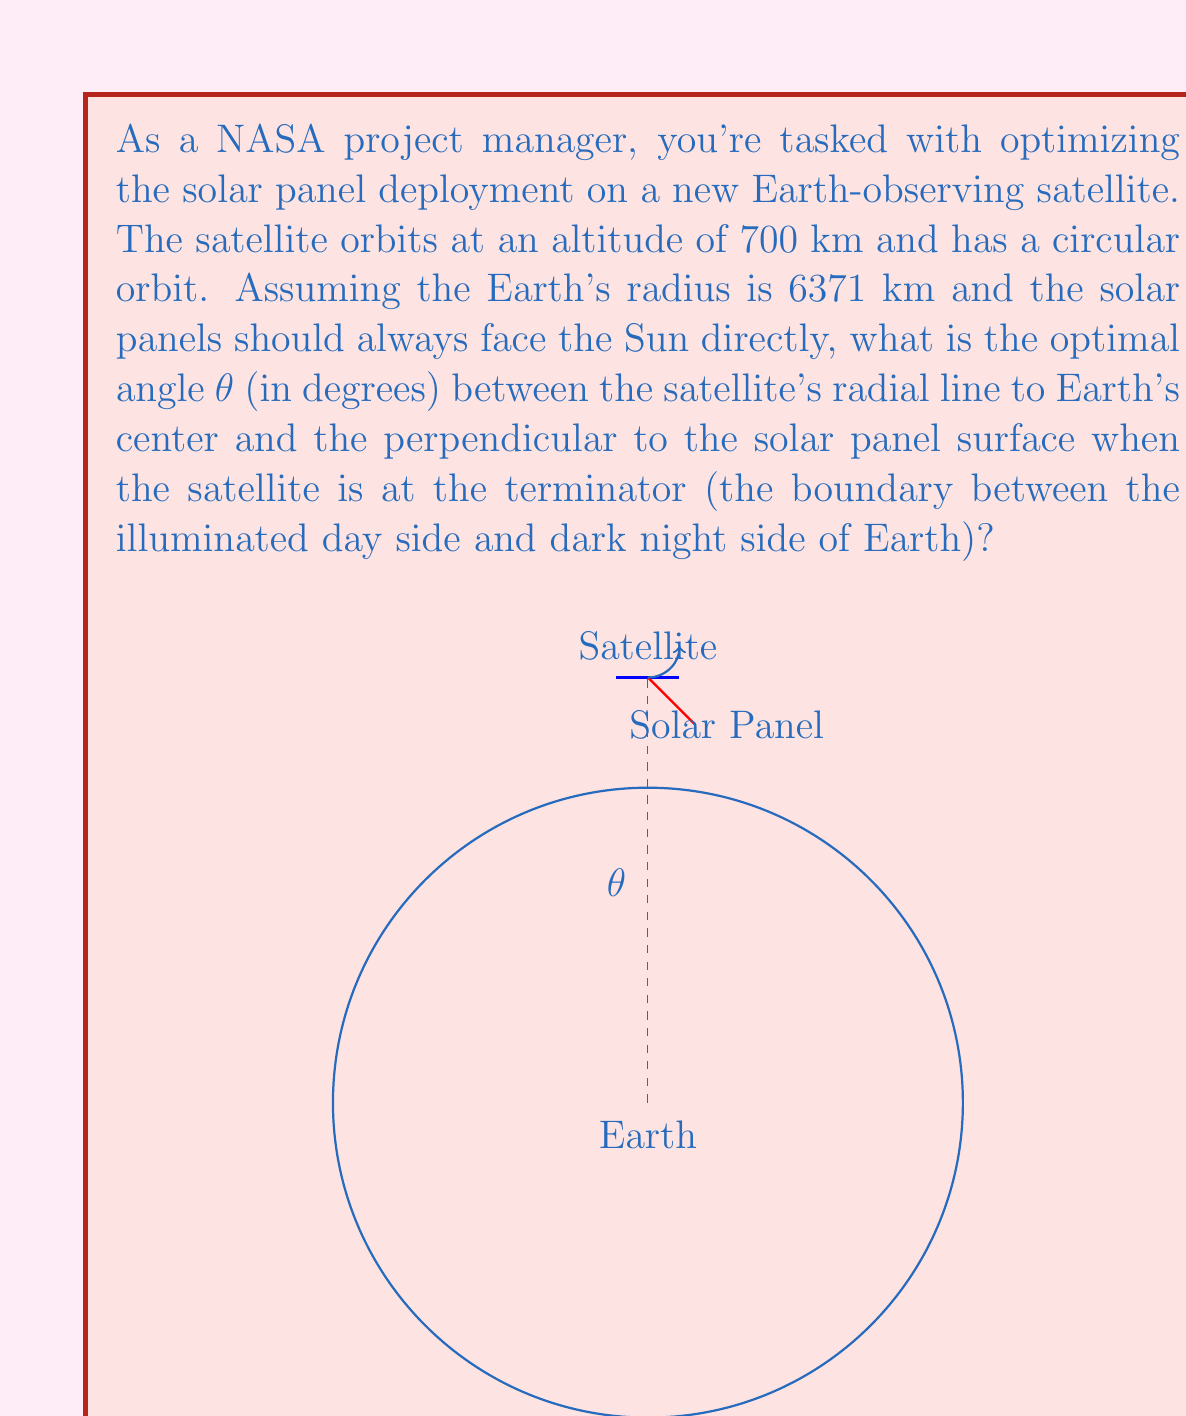Provide a solution to this math problem. To solve this problem, we need to use the geometry of the Earth-satellite system and the concept of the terminator. Let's break it down step-by-step:

1) First, we need to calculate the angle β between the satellite's radial line and the tangent to Earth's surface at the terminator. This angle is complementary to the angle between the radial line and Earth's horizon.

2) We can find this using the cosine of the angle in a right-angled triangle:

   $$\cos \beta = \frac{R_E}{R_E + h}$$

   where $R_E$ is Earth's radius and $h$ is the satellite's altitude.

3) Substituting the values:

   $$\cos \beta = \frac{6371}{6371 + 700} = \frac{6371}{7071} \approx 0.9009$$

4) Taking the inverse cosine:

   $$\beta = \arccos(0.9009) \approx 25.84°$$

5) Now, for the solar panels to face the Sun directly when the satellite is at the terminator, they need to be perpendicular to the Sun's rays. The Sun's rays are tangent to Earth's surface at the terminator.

6) Therefore, the optimal angle θ between the satellite's radial line and the perpendicular to the solar panel surface is the same as β:

   $$\theta = \beta \approx 25.84°$$

This angle ensures that when the satellite crosses the terminator, its solar panels are optimally positioned to capture the Sun's rays as it enters or exits Earth's shadow.
Answer: The optimal angle θ is approximately 25.84°. 